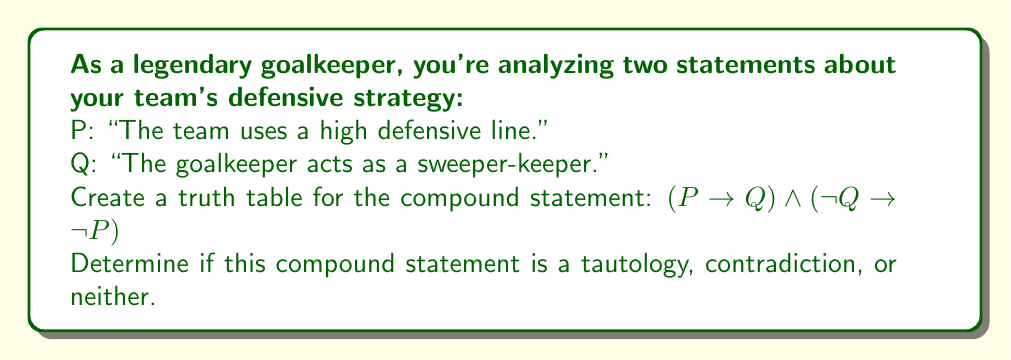Can you solve this math problem? To solve this problem, let's follow these steps:

1) First, we need to create a truth table for the given compound statement. The truth table will have columns for P, Q, and the intermediate steps leading to the final result.

2) The truth table will have 4 rows (2^2) since we have 2 variables (P and Q).

3) Let's break down the compound statement:
   - Part 1: $P \rightarrow Q$
   - Part 2: $\neg Q \rightarrow \neg P$
   - These parts are connected by $\land$ (AND)

4) Here's the truth table:

   $$
   \begin{array}{|c|c|c|c|c|c|c|}
   \hline
   P & Q & P \rightarrow Q & \neg Q & \neg P & \neg Q \rightarrow \neg P & (P \rightarrow Q) \land (\neg Q \rightarrow \neg P) \\
   \hline
   T & T & T & F & F & T & T \\
   T & F & F & T & F & F & F \\
   F & T & T & F & T & T & T \\
   F & F & T & T & T & T & T \\
   \hline
   \end{array}
   $$

5) Explanation of each column:
   - $P \rightarrow Q$ is false only when P is true and Q is false.
   - $\neg Q$ is the negation of Q.
   - $\neg P$ is the negation of P.
   - $\neg Q \rightarrow \neg P$ is false only when $\neg Q$ is true and $\neg P$ is false.
   - The last column is the AND of the two implications.

6) To determine if this compound statement is a tautology, contradiction, or neither:
   - A tautology is always true (all T in the final column).
   - A contradiction is always false (all F in the final column).
   - If it's neither all true nor all false, it's neither a tautology nor a contradiction.

7) Looking at the final column, we see that it's not all true or all false. Therefore, this compound statement is neither a tautology nor a contradiction.
Answer: The compound statement $(P \rightarrow Q) \land (\neg Q \rightarrow \neg P)$ is neither a tautology nor a contradiction. 